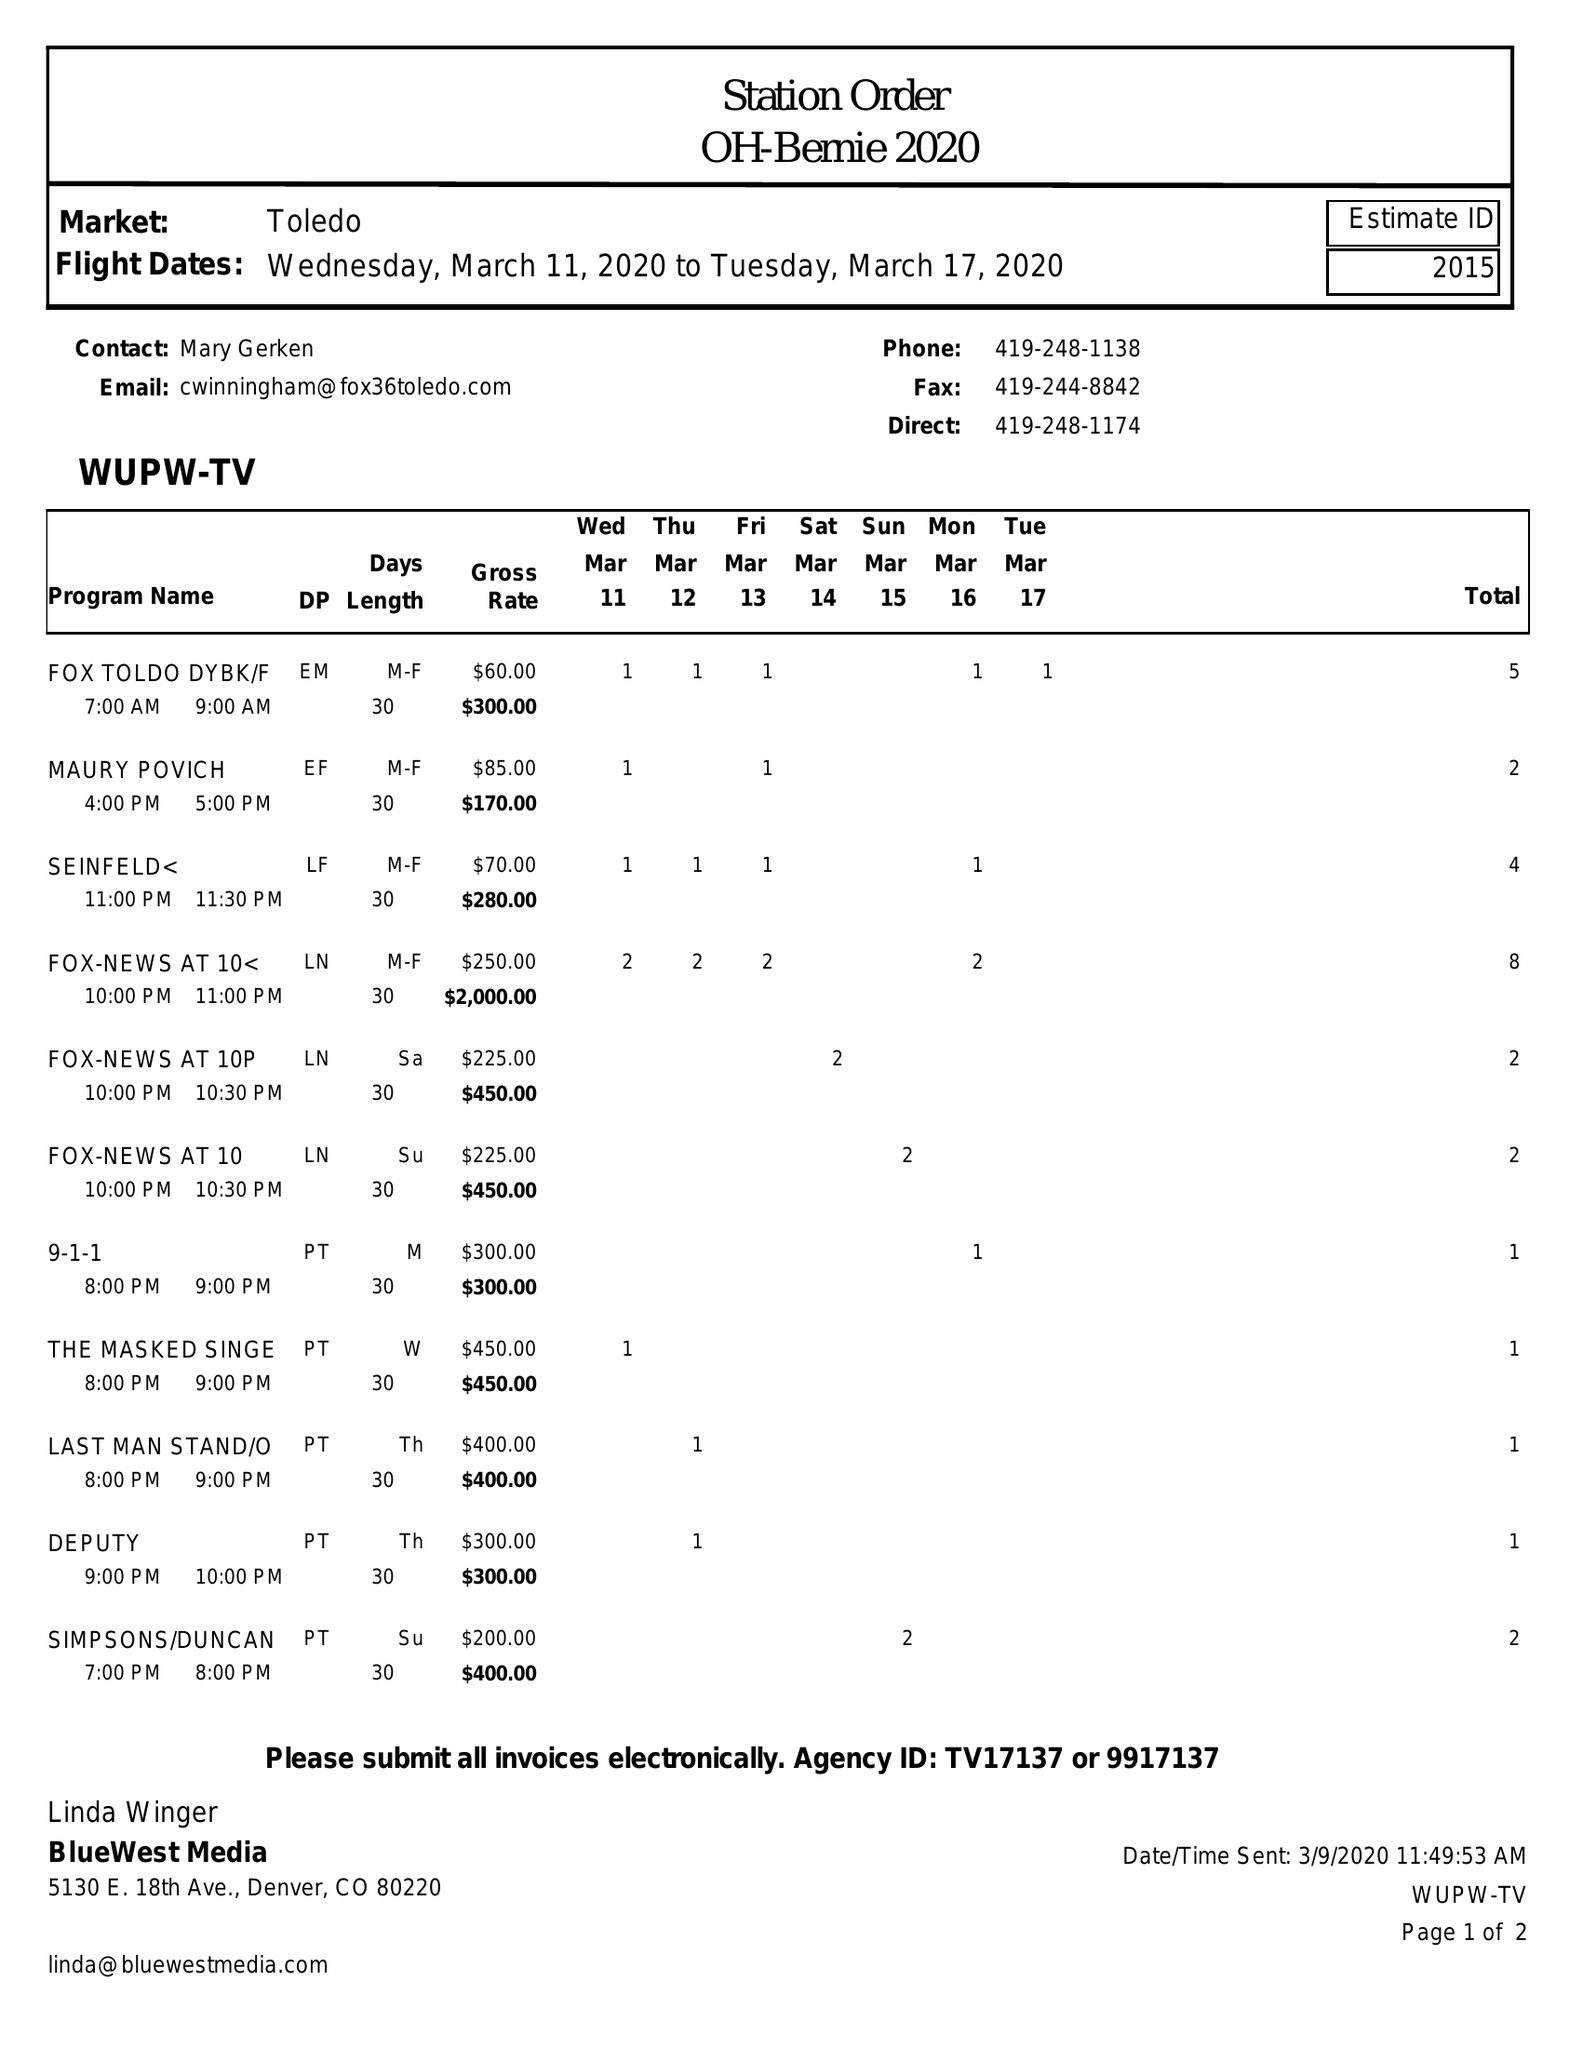What is the value for the contract_num?
Answer the question using a single word or phrase. 2015 